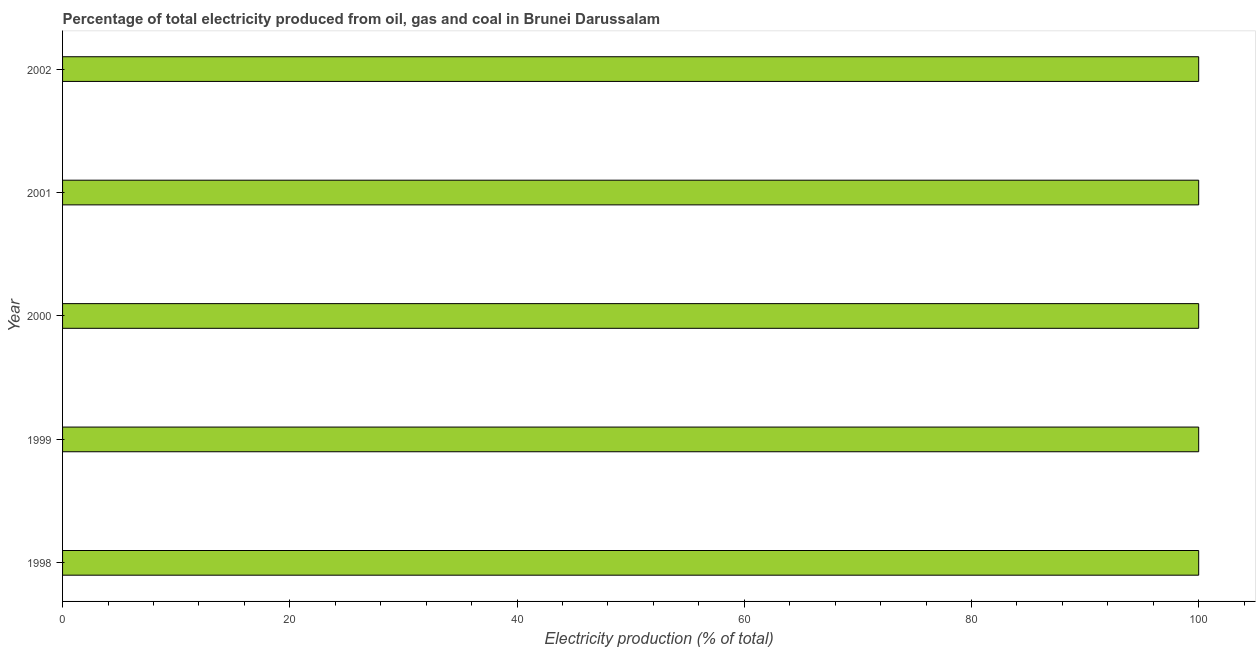Does the graph contain any zero values?
Your answer should be very brief. No. Does the graph contain grids?
Make the answer very short. No. What is the title of the graph?
Keep it short and to the point. Percentage of total electricity produced from oil, gas and coal in Brunei Darussalam. What is the label or title of the X-axis?
Provide a short and direct response. Electricity production (% of total). What is the electricity production in 2000?
Provide a succinct answer. 100. Across all years, what is the maximum electricity production?
Ensure brevity in your answer.  100. Across all years, what is the minimum electricity production?
Your response must be concise. 100. In which year was the electricity production minimum?
Provide a short and direct response. 1998. What is the difference between the electricity production in 1998 and 1999?
Provide a short and direct response. 0. What is the median electricity production?
Provide a succinct answer. 100. Is the electricity production in 1998 less than that in 2002?
Your answer should be compact. No. Is the difference between the electricity production in 2000 and 2002 greater than the difference between any two years?
Offer a terse response. Yes. What is the difference between the highest and the second highest electricity production?
Your response must be concise. 0. Is the sum of the electricity production in 1999 and 2001 greater than the maximum electricity production across all years?
Your answer should be compact. Yes. In how many years, is the electricity production greater than the average electricity production taken over all years?
Your response must be concise. 0. Are all the bars in the graph horizontal?
Your answer should be very brief. Yes. What is the Electricity production (% of total) in 1998?
Offer a very short reply. 100. What is the Electricity production (% of total) in 2000?
Keep it short and to the point. 100. What is the Electricity production (% of total) of 2001?
Offer a terse response. 100. What is the Electricity production (% of total) of 2002?
Keep it short and to the point. 100. What is the difference between the Electricity production (% of total) in 1998 and 1999?
Keep it short and to the point. 0. What is the difference between the Electricity production (% of total) in 1998 and 2000?
Make the answer very short. 0. What is the difference between the Electricity production (% of total) in 1998 and 2002?
Your response must be concise. 0. What is the difference between the Electricity production (% of total) in 1999 and 2002?
Your answer should be very brief. 0. What is the difference between the Electricity production (% of total) in 2000 and 2002?
Your answer should be compact. 0. What is the difference between the Electricity production (% of total) in 2001 and 2002?
Your response must be concise. 0. What is the ratio of the Electricity production (% of total) in 1998 to that in 1999?
Your response must be concise. 1. What is the ratio of the Electricity production (% of total) in 1999 to that in 2000?
Make the answer very short. 1. What is the ratio of the Electricity production (% of total) in 2001 to that in 2002?
Ensure brevity in your answer.  1. 